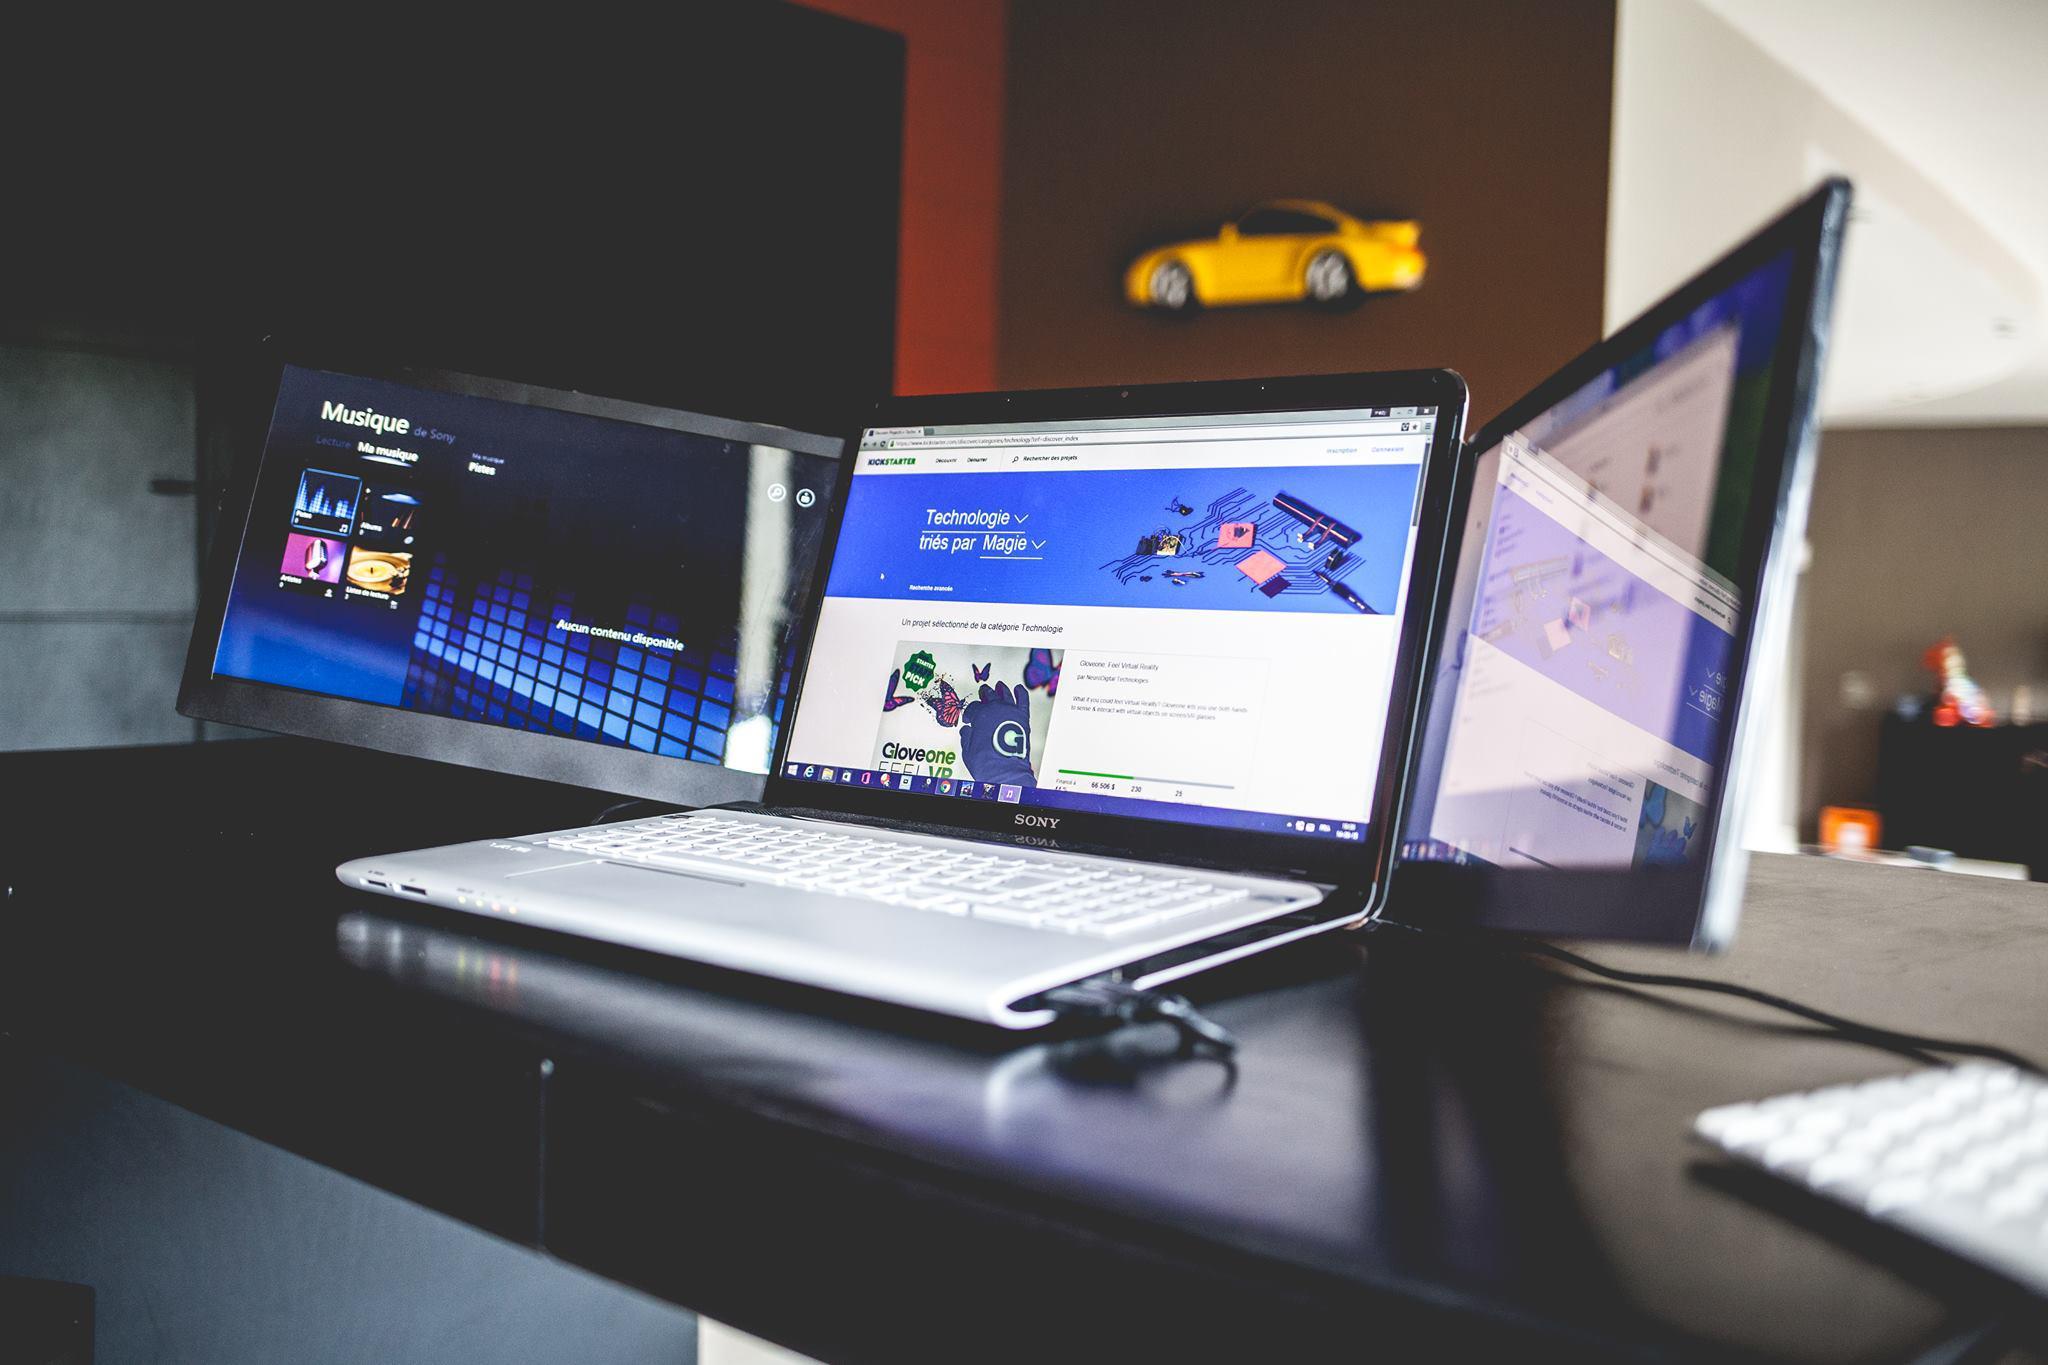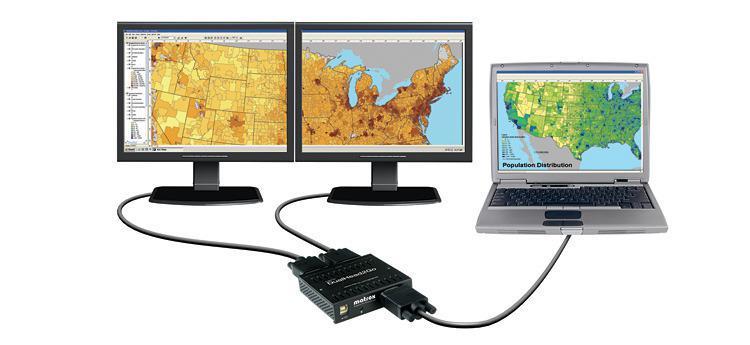The first image is the image on the left, the second image is the image on the right. For the images displayed, is the sentence "Three computer screens are lined up in each picture." factually correct? Answer yes or no. Yes. The first image is the image on the left, the second image is the image on the right. For the images shown, is this caption "The external monitors are showing the same image as the laptop." true? Answer yes or no. No. 